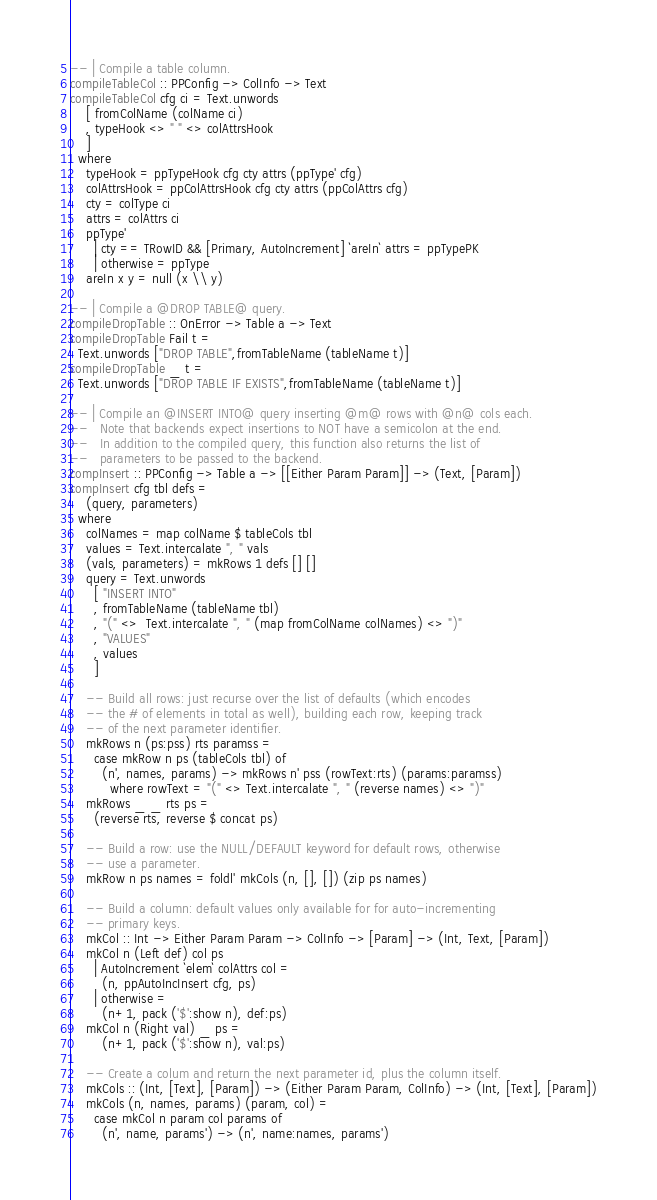Convert code to text. <code><loc_0><loc_0><loc_500><loc_500><_Haskell_>
-- | Compile a table column.
compileTableCol :: PPConfig -> ColInfo -> Text
compileTableCol cfg ci = Text.unwords
    [ fromColName (colName ci)
    , typeHook <> " " <> colAttrsHook
    ]
  where
    typeHook = ppTypeHook cfg cty attrs (ppType' cfg)
    colAttrsHook = ppColAttrsHook cfg cty attrs (ppColAttrs cfg)
    cty = colType ci
    attrs = colAttrs ci
    ppType'
      | cty == TRowID && [Primary, AutoIncrement] `areIn` attrs = ppTypePK
      | otherwise = ppType
    areIn x y = null (x \\ y)

-- | Compile a @DROP TABLE@ query.
compileDropTable :: OnError -> Table a -> Text
compileDropTable Fail t =
  Text.unwords ["DROP TABLE",fromTableName (tableName t)]
compileDropTable _ t =
  Text.unwords ["DROP TABLE IF EXISTS",fromTableName (tableName t)]

-- | Compile an @INSERT INTO@ query inserting @m@ rows with @n@ cols each.
--   Note that backends expect insertions to NOT have a semicolon at the end.
--   In addition to the compiled query, this function also returns the list of
--   parameters to be passed to the backend.
compInsert :: PPConfig -> Table a -> [[Either Param Param]] -> (Text, [Param])
compInsert cfg tbl defs =
    (query, parameters)
  where
    colNames = map colName $ tableCols tbl
    values = Text.intercalate ", " vals
    (vals, parameters) = mkRows 1 defs [] []
    query = Text.unwords
      [ "INSERT INTO"
      , fromTableName (tableName tbl)
      , "(" <>  Text.intercalate ", " (map fromColName colNames) <> ")"
      , "VALUES"
      , values
      ]

    -- Build all rows: just recurse over the list of defaults (which encodes
    -- the # of elements in total as well), building each row, keeping track
    -- of the next parameter identifier.
    mkRows n (ps:pss) rts paramss =
      case mkRow n ps (tableCols tbl) of
        (n', names, params) -> mkRows n' pss (rowText:rts) (params:paramss)
          where rowText = "(" <> Text.intercalate ", " (reverse names) <> ")"
    mkRows _ _ rts ps =
      (reverse rts, reverse $ concat ps)

    -- Build a row: use the NULL/DEFAULT keyword for default rows, otherwise
    -- use a parameter.
    mkRow n ps names = foldl' mkCols (n, [], []) (zip ps names)

    -- Build a column: default values only available for for auto-incrementing
    -- primary keys.
    mkCol :: Int -> Either Param Param -> ColInfo -> [Param] -> (Int, Text, [Param])
    mkCol n (Left def) col ps
      | AutoIncrement `elem` colAttrs col =
        (n, ppAutoIncInsert cfg, ps)
      | otherwise =
        (n+1, pack ('$':show n), def:ps)
    mkCol n (Right val) _ ps =
        (n+1, pack ('$':show n), val:ps)

    -- Create a colum and return the next parameter id, plus the column itself.
    mkCols :: (Int, [Text], [Param]) -> (Either Param Param, ColInfo) -> (Int, [Text], [Param])
    mkCols (n, names, params) (param, col) =
      case mkCol n param col params of
        (n', name, params') -> (n', name:names, params')
</code> 